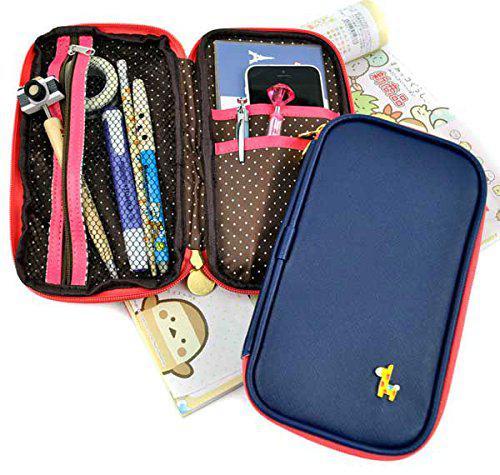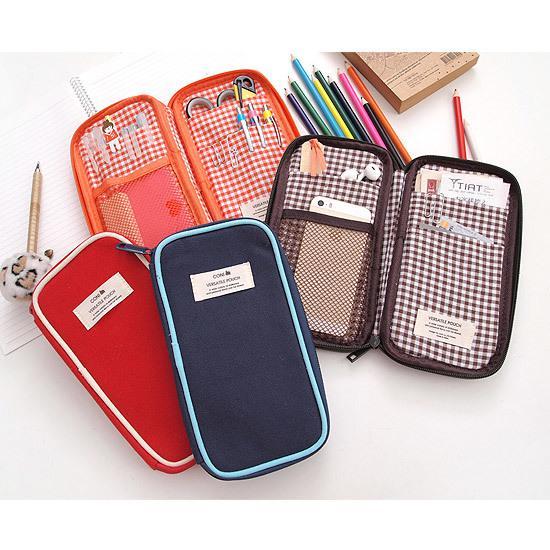The first image is the image on the left, the second image is the image on the right. Given the left and right images, does the statement "The left image shows exactly four pencil cases on a white background." hold true? Answer yes or no. No. 